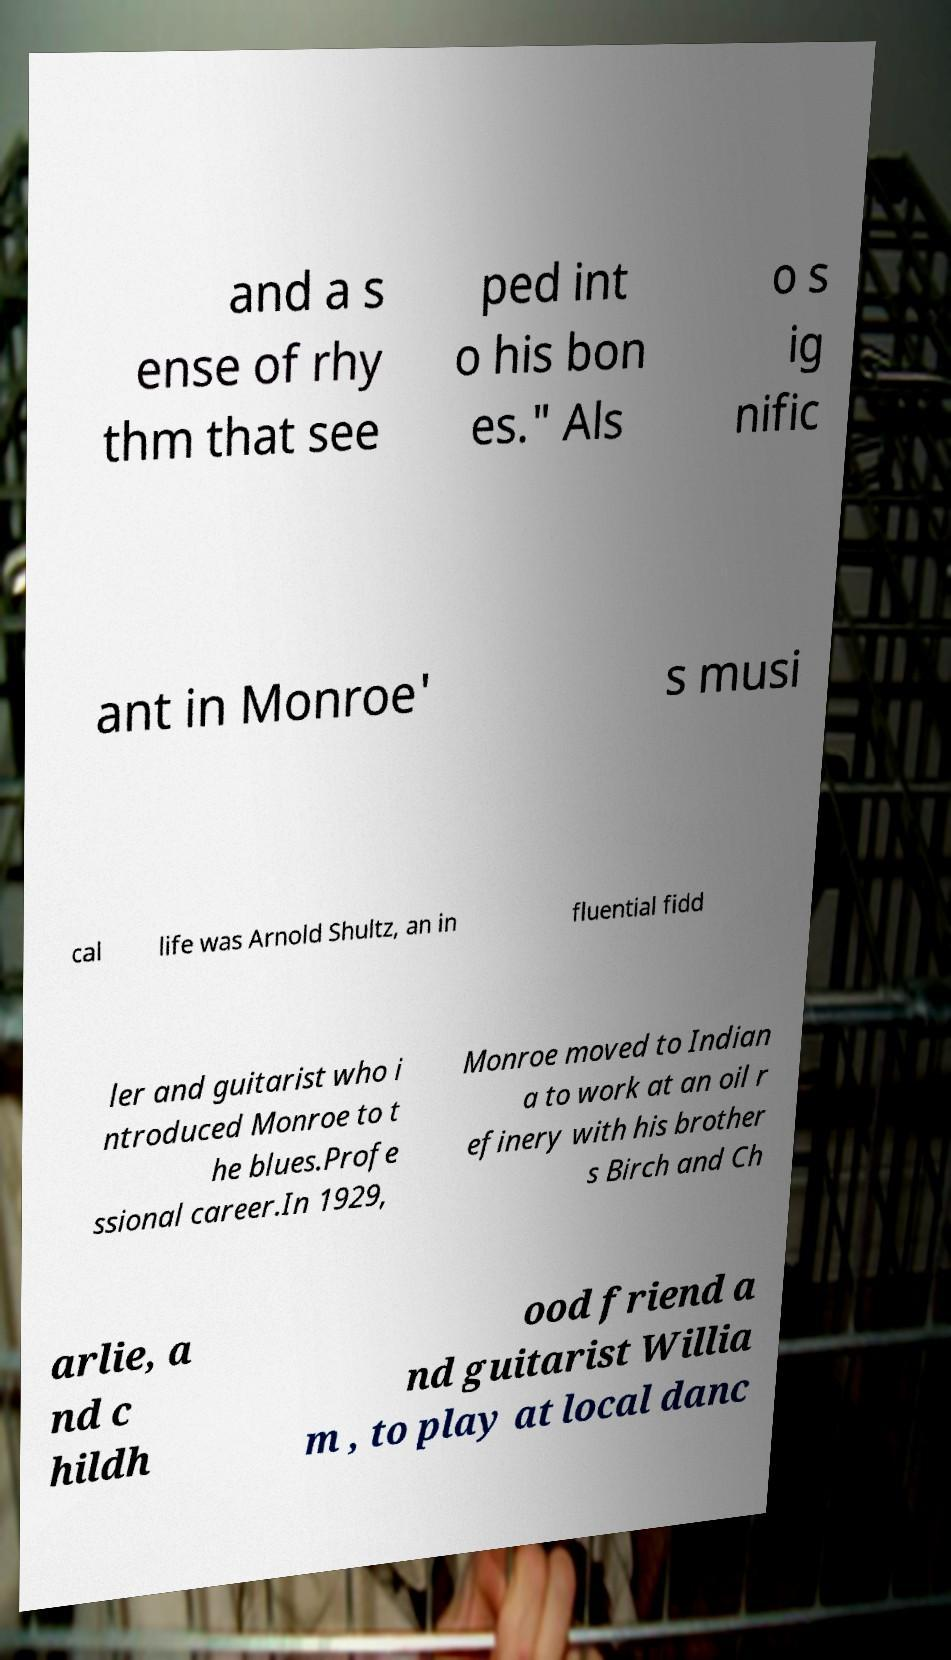There's text embedded in this image that I need extracted. Can you transcribe it verbatim? and a s ense of rhy thm that see ped int o his bon es." Als o s ig nific ant in Monroe' s musi cal life was Arnold Shultz, an in fluential fidd ler and guitarist who i ntroduced Monroe to t he blues.Profe ssional career.In 1929, Monroe moved to Indian a to work at an oil r efinery with his brother s Birch and Ch arlie, a nd c hildh ood friend a nd guitarist Willia m , to play at local danc 